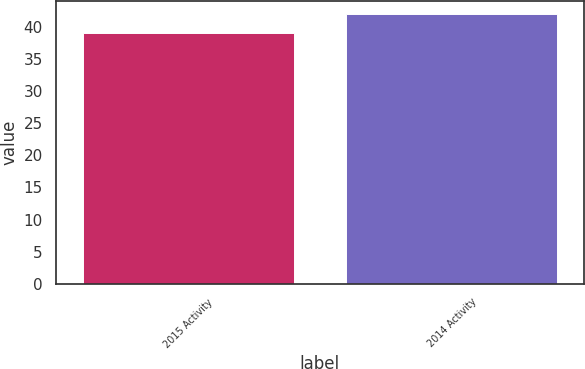Convert chart to OTSL. <chart><loc_0><loc_0><loc_500><loc_500><bar_chart><fcel>2015 Activity<fcel>2014 Activity<nl><fcel>39<fcel>42<nl></chart> 